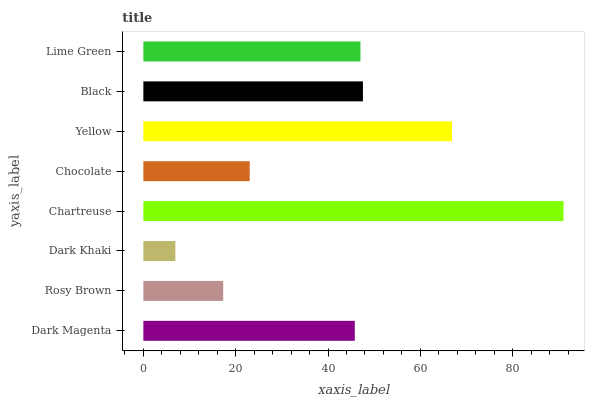Is Dark Khaki the minimum?
Answer yes or no. Yes. Is Chartreuse the maximum?
Answer yes or no. Yes. Is Rosy Brown the minimum?
Answer yes or no. No. Is Rosy Brown the maximum?
Answer yes or no. No. Is Dark Magenta greater than Rosy Brown?
Answer yes or no. Yes. Is Rosy Brown less than Dark Magenta?
Answer yes or no. Yes. Is Rosy Brown greater than Dark Magenta?
Answer yes or no. No. Is Dark Magenta less than Rosy Brown?
Answer yes or no. No. Is Lime Green the high median?
Answer yes or no. Yes. Is Dark Magenta the low median?
Answer yes or no. Yes. Is Dark Khaki the high median?
Answer yes or no. No. Is Chartreuse the low median?
Answer yes or no. No. 